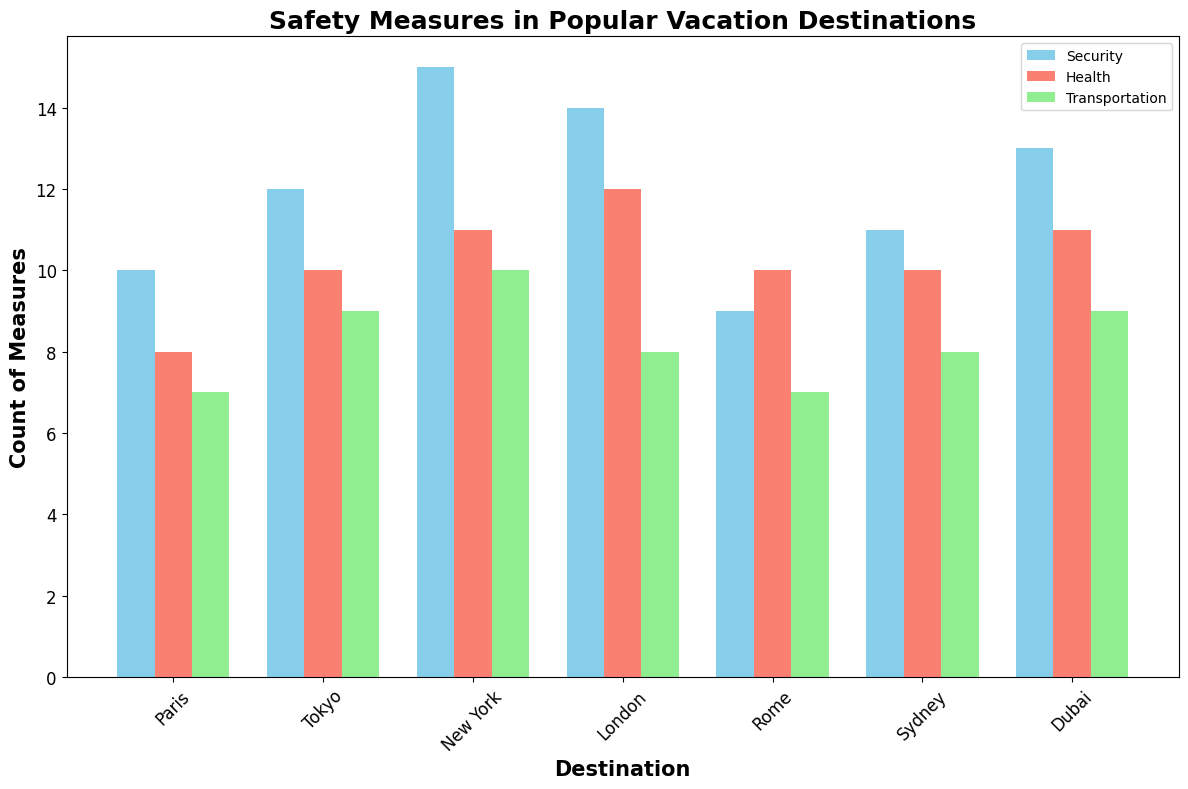Which destination has the highest number of security measures? Find the security measures bar (in sky blue) that is the tallest in the plot. The tallest bar belongs to New York.
Answer: New York How many total safety measures are implemented in Paris? Sum the counts of security, health, and transportation measures for Paris from their respective bars: Security (10) + Health (8) + Transportation (7).
Answer: 25 Which destination has more health measures than transportation measures? Compare the health and transportation measures bars (salmon and light green, respectively) for each destination. All destinations except Rome have more health measures than transportation measures.
Answer: Paris, Tokyo, New York, London, Sydney, Dubai What is the difference between the highest and the lowest number of security measures among the destinations? Identify the highest and the lowest security measures from the sky blue bars: Highest (New York, 15), Lowest (Rome, 9). Calculate the difference (15 - 9).
Answer: 6 Are there any destinations where the count of health measures equals the count of transportation measures? Compare the heights of the salmon and light green bars for each destination. For both Rome and Sydney, health measures count equals transportation measures count.
Answer: Rome, Sydney How do the number of health measures in London compare to those in Dubai? Observe the heights of the salmon bars for London and Dubai. Both have 11 health measures.
Answer: Equal Which destination has the most balanced implementation of safety measures across all three types? Look for a destination where the heights of the three bars are closest in value. Tokyo and Sydney seem balanced with 12, 10, 9 and 11, 10, 8 respectively, but Tokyo is slightly more balanced.
Answer: Tokyo What is the combined number of transportation measures in all destinations? Sum the counts of transportation measures from the light green bars for each destination: 7 (Paris) + 9 (Tokyo) + 10 (New York) + 8 (London) + 7 (Rome) + 8 (Sydney) + 9 (Dubai).
Answer: 58 